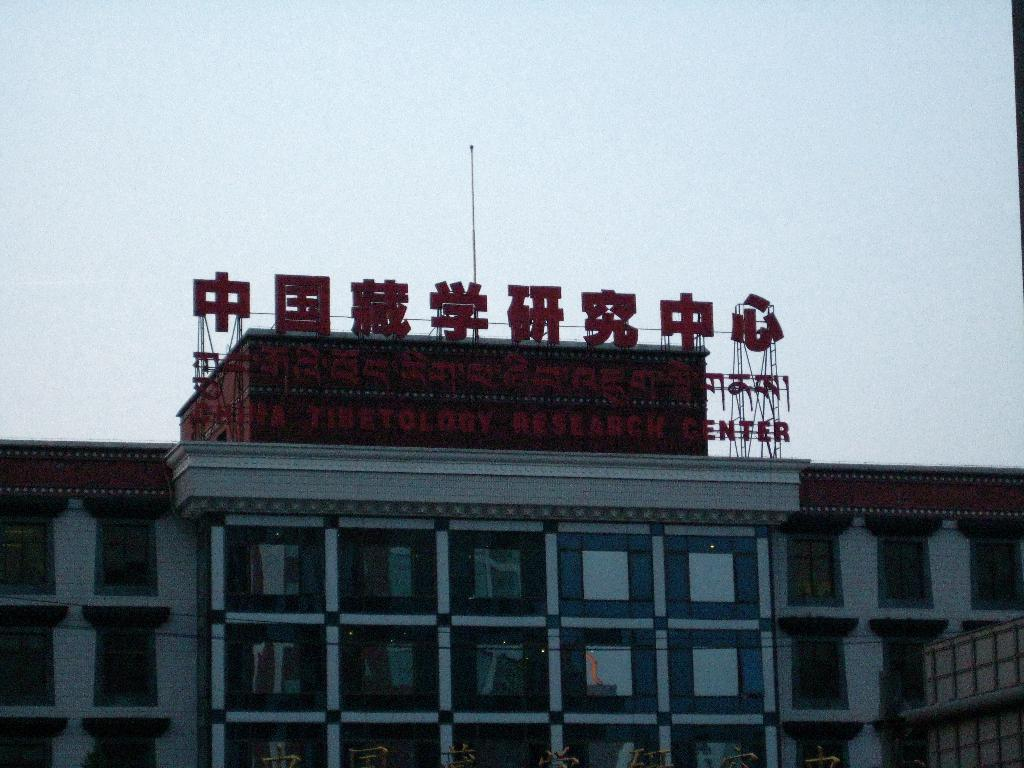What type of structure is present in the image? There is a building in the image. Where is the building located in relation to the image? The building is at the bottom of the image. What can be seen above the building in the image? The sky is visible at the top of the image. How many children are on the journey depicted in the image? There are no children or journey depicted in the image; it only features a building and the sky. 